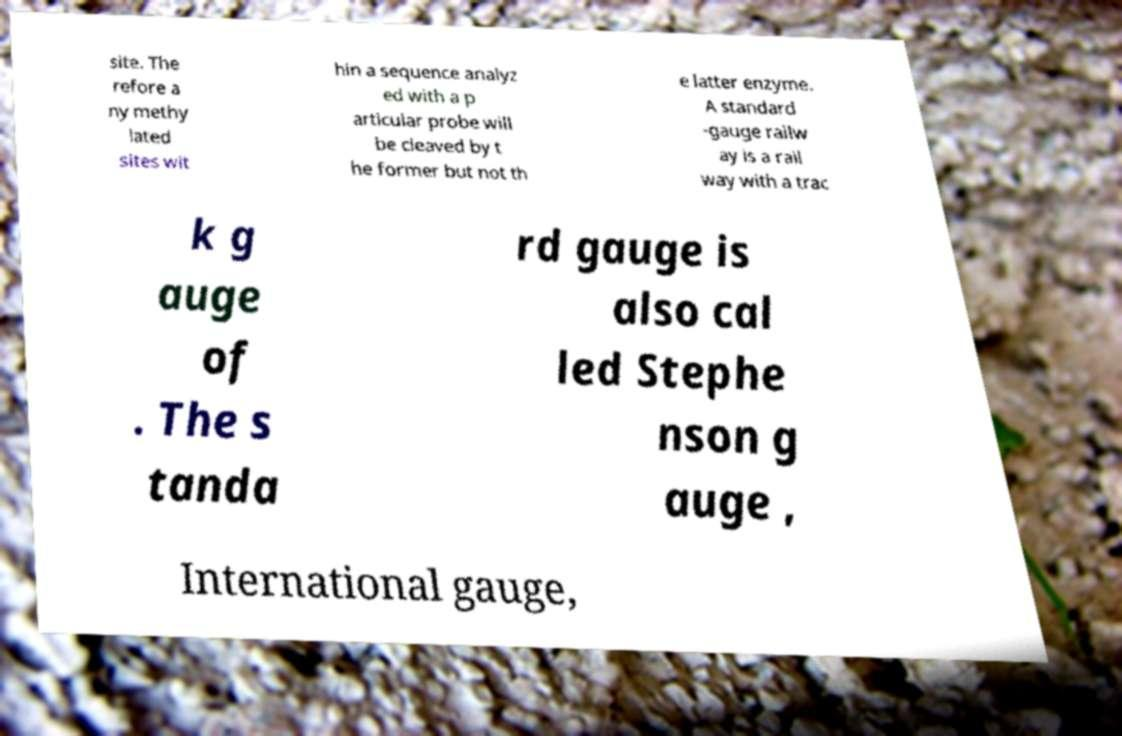Please read and relay the text visible in this image. What does it say? site. The refore a ny methy lated sites wit hin a sequence analyz ed with a p articular probe will be cleaved by t he former but not th e latter enzyme. A standard -gauge railw ay is a rail way with a trac k g auge of . The s tanda rd gauge is also cal led Stephe nson g auge , International gauge, 